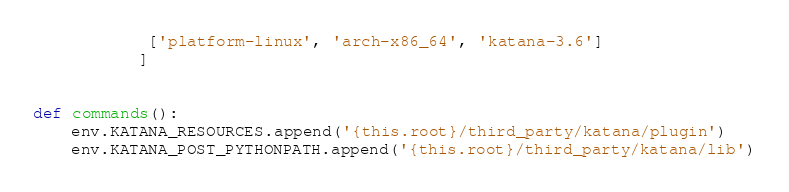<code> <loc_0><loc_0><loc_500><loc_500><_Python_>            ['platform-linux', 'arch-x86_64', 'katana-3.6']
           ]


def commands():
    env.KATANA_RESOURCES.append('{this.root}/third_party/katana/plugin')
    env.KATANA_POST_PYTHONPATH.append('{this.root}/third_party/katana/lib')

</code> 